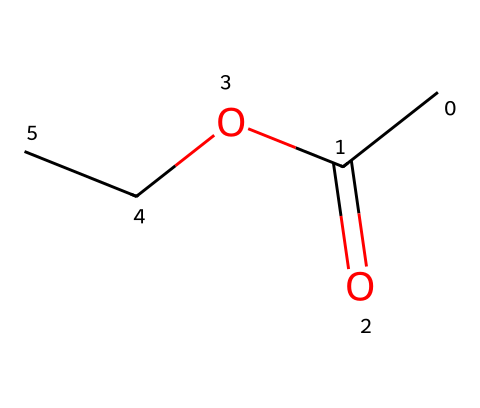What is the name of this chemical? The structural formula corresponds to ethyl acetate, which is a well-known ester. The SMILES representation offers clues to its naming, indicating it consists of an ethyl group and an acetate part, confirming the name.
Answer: ethyl acetate How many carbon atoms are in this molecule? Counting from the SMILES representation, there are 4 carbon atoms total: 2 in the ethyl group and 2 in the carbonyl and acetate group. Therefore, the total is 4.
Answer: 4 What type of functional group is present in ethyl acetate? The SMILES notation shows the presence of a carbonyl group (C=O) and an ether-like linkage (C-O-C), which are characteristic of esters, confirming that the functional group is an ester.
Answer: ester What is the total number of hydrogen atoms in this molecule? Each carbon contributes typically 2 or 3 hydrogens based on bonding, and by analyzing the structure: the ethyl (2 from CH3 and 2 from CH2) contributes 5, while the acetate part contributes 2 more, making a total of 6.
Answer: 8 What property is typically associated with esters like ethyl acetate? Esters are known for their fruity aromas, and ethyl acetate specifically has a pleasant, fruity smell, commonly used in perfumes and flavorings due to this characteristic property.
Answer: fruity smell Is this molecule polar or non-polar? Examining the structure shows the presence of polar functional groups (the carbonyl and ether link), indicating that ethyl acetate is polar, which affects its solubility and interactions in different environments.
Answer: polar 